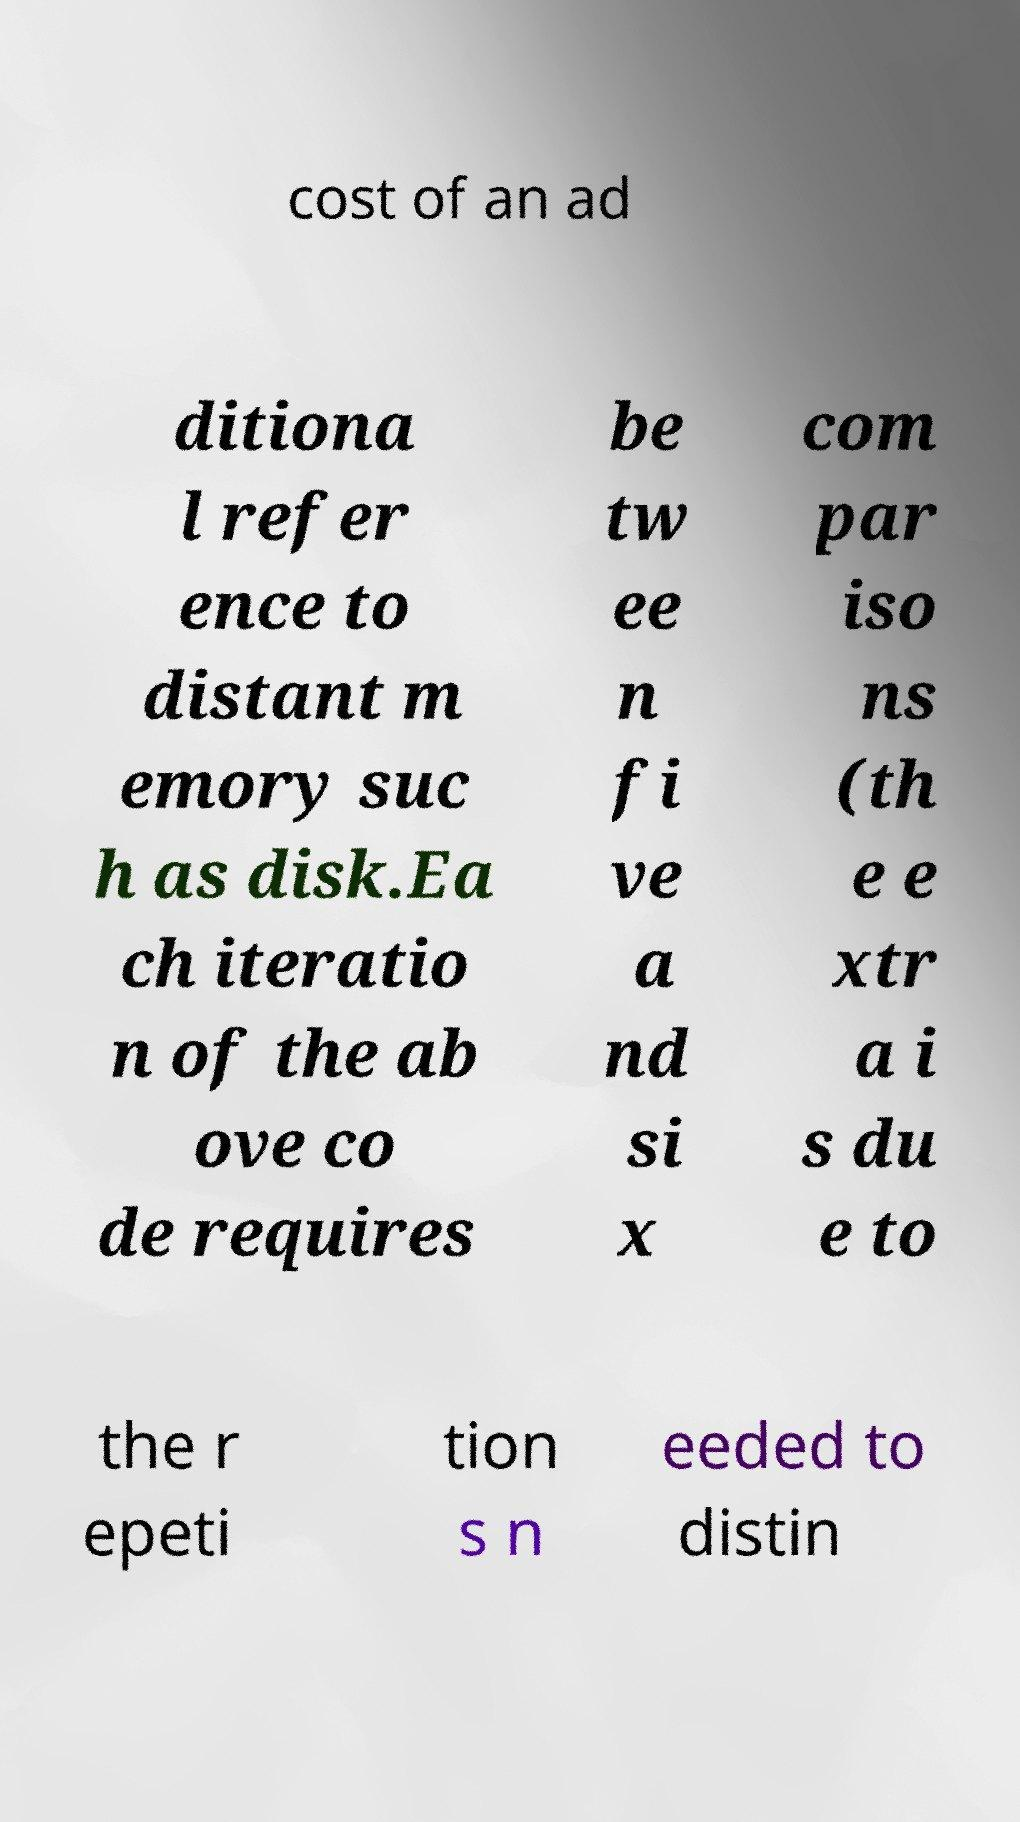Could you extract and type out the text from this image? cost of an ad ditiona l refer ence to distant m emory suc h as disk.Ea ch iteratio n of the ab ove co de requires be tw ee n fi ve a nd si x com par iso ns (th e e xtr a i s du e to the r epeti tion s n eeded to distin 